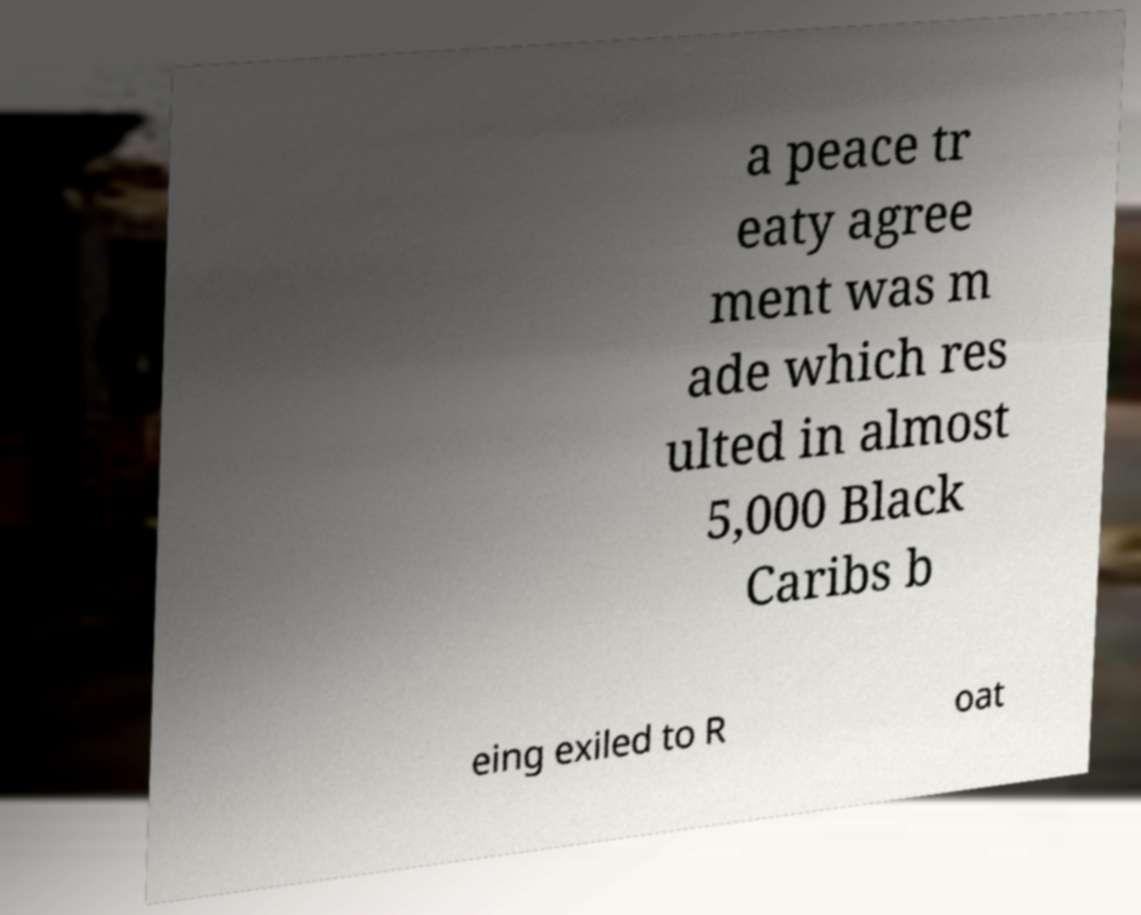Could you assist in decoding the text presented in this image and type it out clearly? a peace tr eaty agree ment was m ade which res ulted in almost 5,000 Black Caribs b eing exiled to R oat 